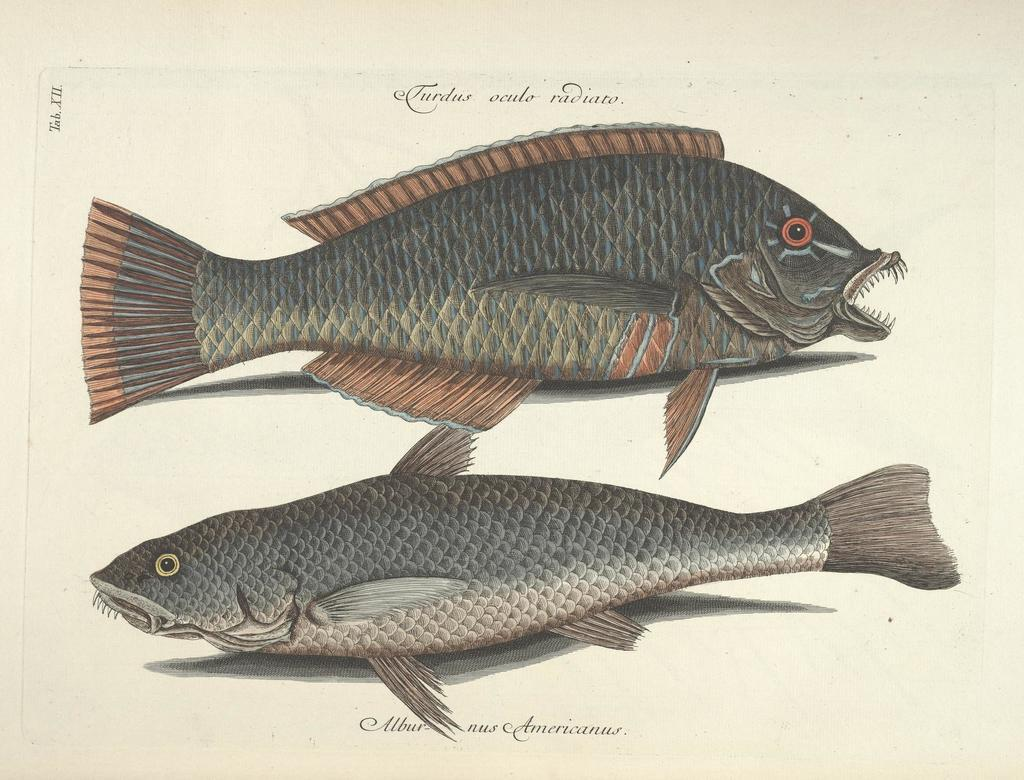What is the main subject of the image? The main subject of the image is an art of fishes. Can you describe any additional elements in the image? Yes, there is text present in the image. What type of corn is being stored in the tin container in the image? There is no corn or tin container present in the image; it features an art of fishes and text. How much salt is sprinkled on the fish in the image? There is no salt present in the image; it only shows an art of fishes and text. 